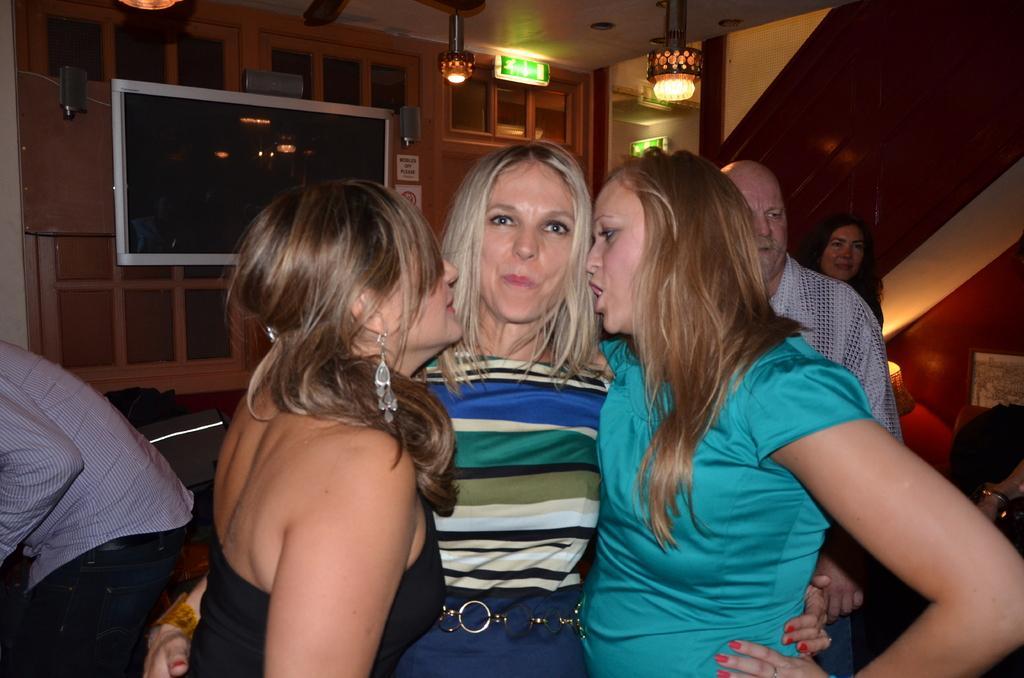Can you describe this image briefly? This is an inside view of a room. Here I can see three women are standing. The woman who is in the middle is looking at the picture and other two women are facing at this woman. In the background, I can see some more people are standing. In the background a screen is attached to the wall, a couch, lamp and some other objects are placed. On the top I can see some lights and a wall. 